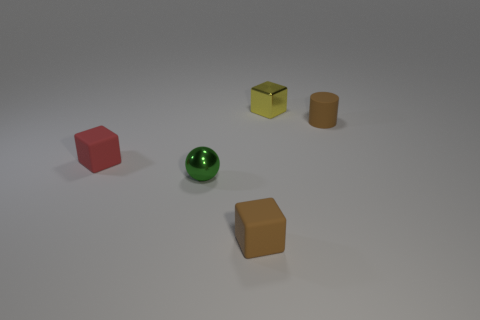Add 3 tiny yellow blocks. How many objects exist? 8 Subtract all tiny brown blocks. How many blocks are left? 2 Add 5 tiny matte objects. How many tiny matte objects are left? 8 Add 1 small red matte blocks. How many small red matte blocks exist? 2 Subtract all red blocks. How many blocks are left? 2 Subtract 0 green cubes. How many objects are left? 5 Subtract all spheres. How many objects are left? 4 Subtract 2 blocks. How many blocks are left? 1 Subtract all yellow spheres. Subtract all yellow cylinders. How many spheres are left? 1 Subtract all blue cylinders. How many red blocks are left? 1 